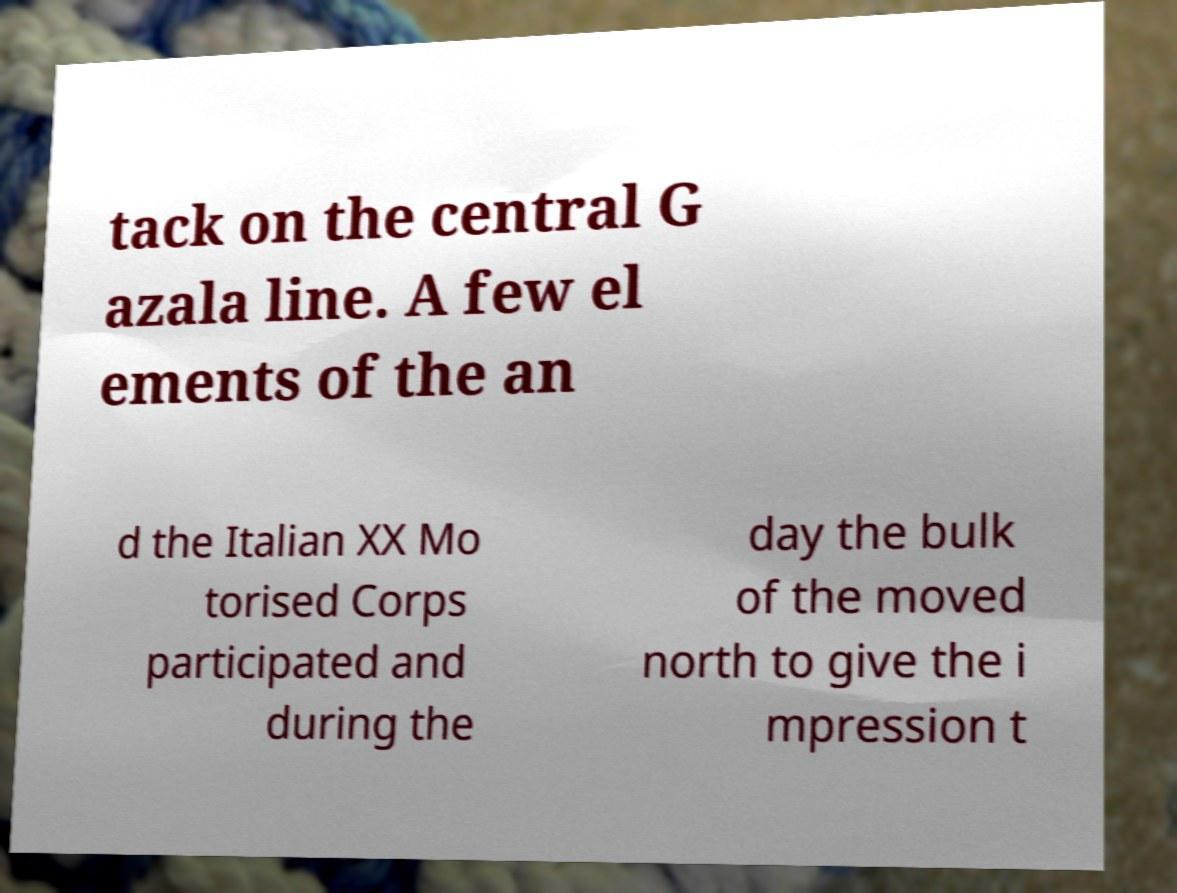Please read and relay the text visible in this image. What does it say? tack on the central G azala line. A few el ements of the an d the Italian XX Mo torised Corps participated and during the day the bulk of the moved north to give the i mpression t 